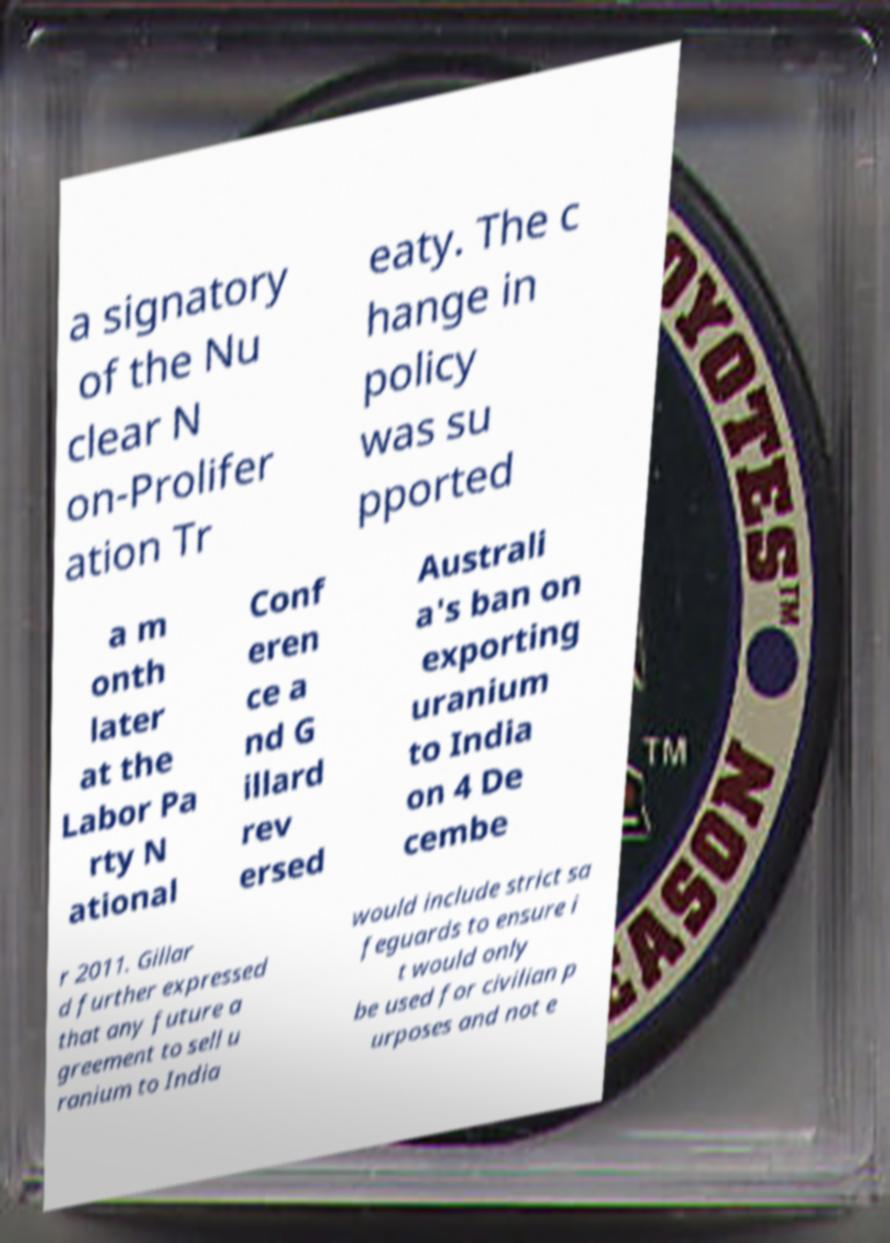Please identify and transcribe the text found in this image. a signatory of the Nu clear N on-Prolifer ation Tr eaty. The c hange in policy was su pported a m onth later at the Labor Pa rty N ational Conf eren ce a nd G illard rev ersed Australi a's ban on exporting uranium to India on 4 De cembe r 2011. Gillar d further expressed that any future a greement to sell u ranium to India would include strict sa feguards to ensure i t would only be used for civilian p urposes and not e 